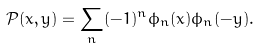Convert formula to latex. <formula><loc_0><loc_0><loc_500><loc_500>\mathcal { P } ( x , y ) = \sum _ { n } ( - 1 ) ^ { n } \phi _ { n } ( x ) \phi _ { n } ( - y ) .</formula> 